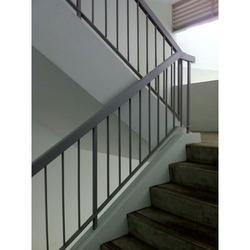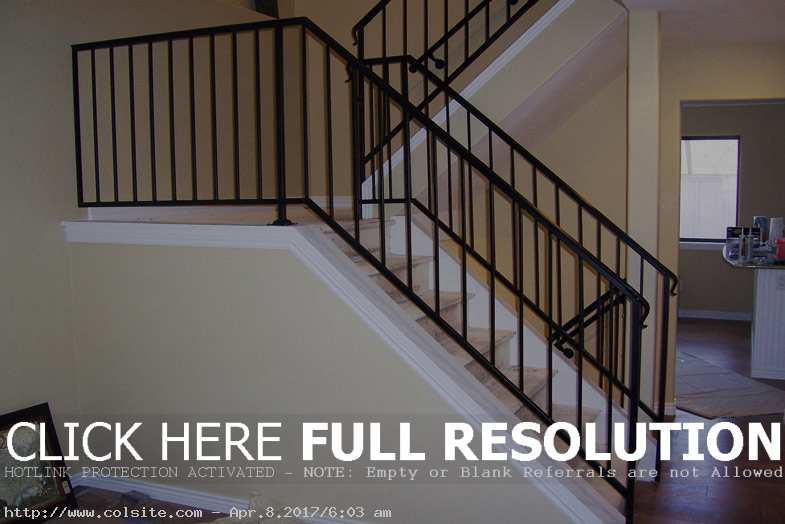The first image is the image on the left, the second image is the image on the right. Examine the images to the left and right. Is the description "One image features backless stairs that ascend in a spiral pattern from an upright pole in the center." accurate? Answer yes or no. No. The first image is the image on the left, the second image is the image on the right. Considering the images on both sides, is "The staircase in one of the images spirals its way down." valid? Answer yes or no. No. 